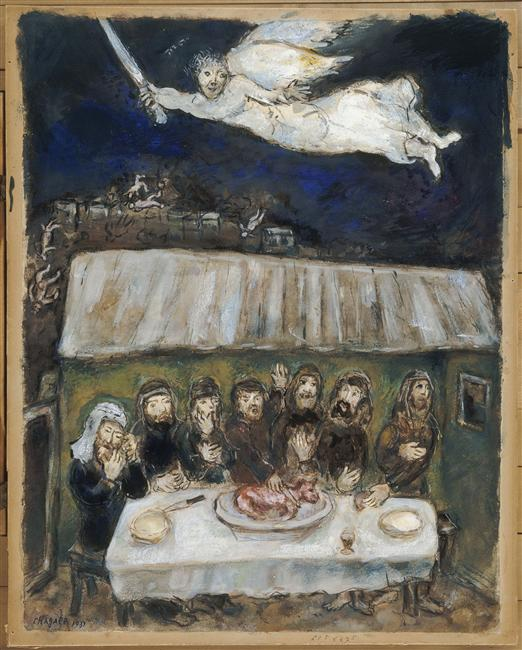Could you tell me more about the expressions and postures of the people at the table? The people at the table exhibit a range of expressions, from awe to solemnity, which collectively contribute to the painting's intense emotional atmosphere. Their postures, mostly upright and slightly leaning forward, indicate a shared focus and perhaps a common concern or anticipation of the event symbolized by the angelic figure's descent. Each character's unique reaction helps create a narrative that viewers can interpret in various ways. 